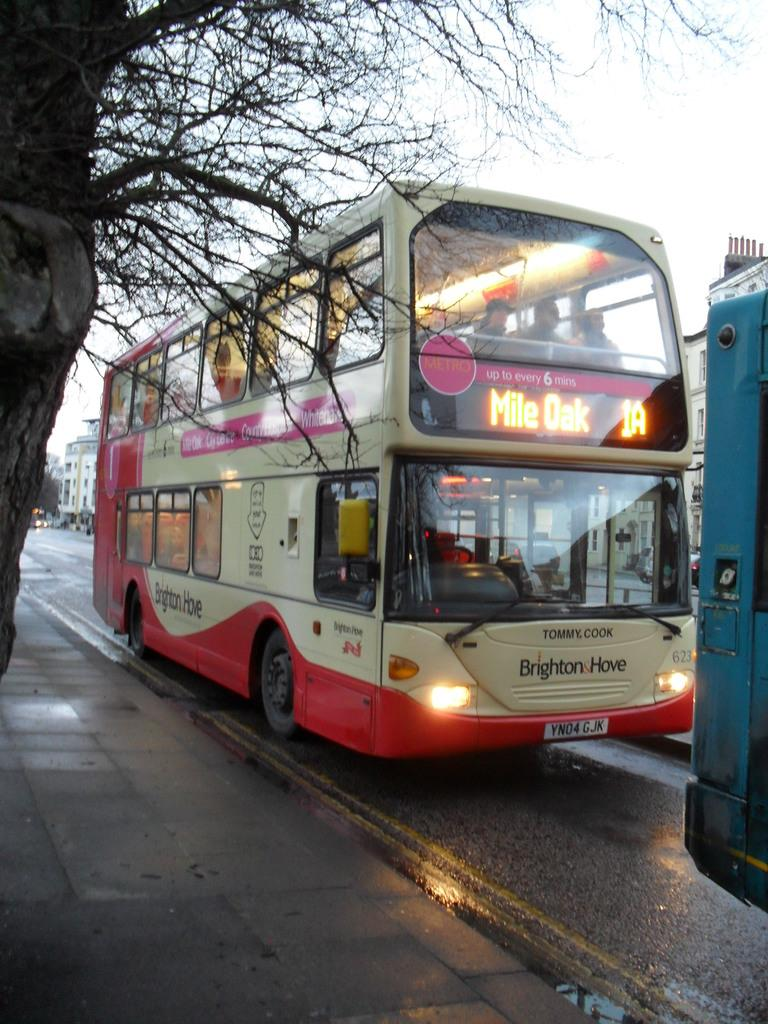What can be seen on the road in the image? There are vehicles on the road in the image. What is located to the left of the image? There is a tree to the left of the image. What is located to the right of the image? There are buildings and trees to the right of the image. What is visible in the background of the image? The sky is visible in the image. What type of birthday celebration is happening in the image? There is no indication of a birthday celebration in the image. Can you describe the game that the children are playing in the image? There are no children or games present in the image. 